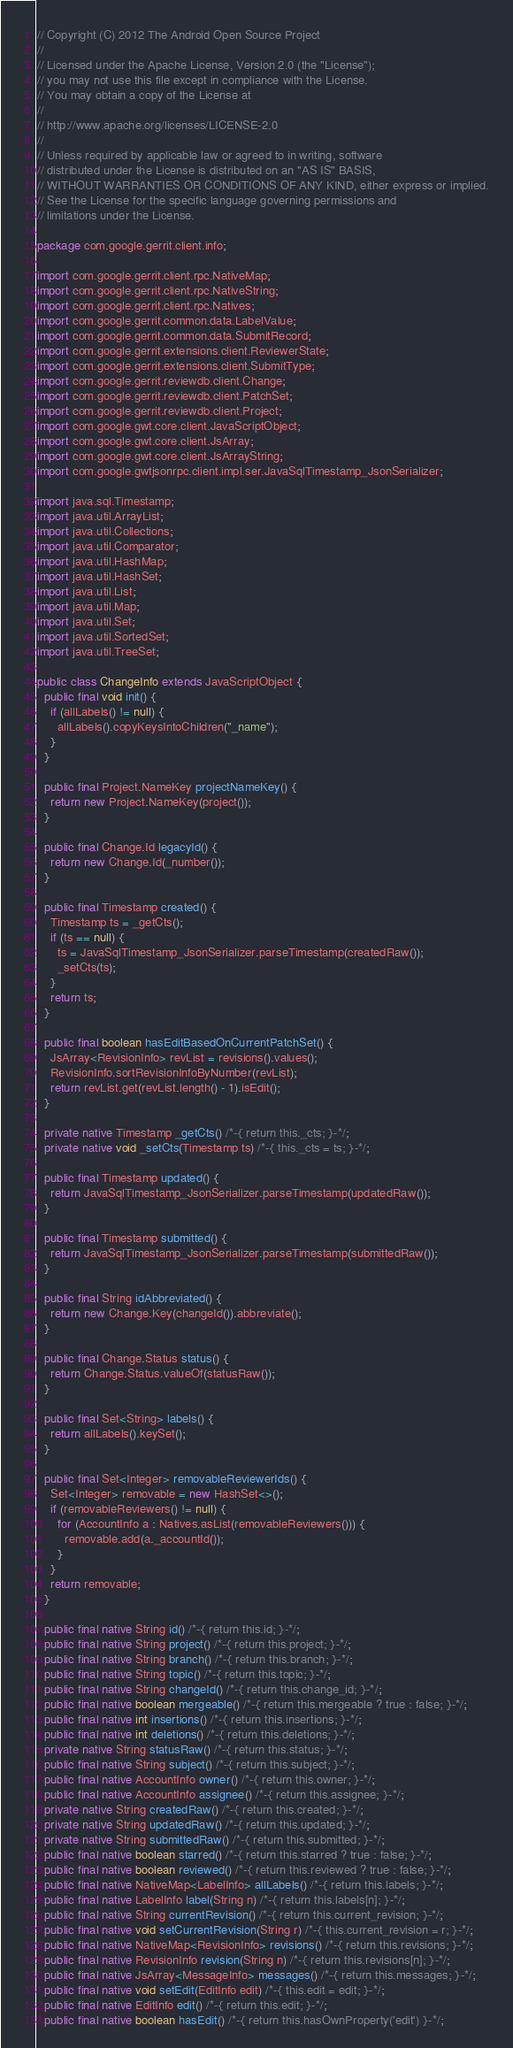<code> <loc_0><loc_0><loc_500><loc_500><_Java_>// Copyright (C) 2012 The Android Open Source Project
//
// Licensed under the Apache License, Version 2.0 (the "License");
// you may not use this file except in compliance with the License.
// You may obtain a copy of the License at
//
// http://www.apache.org/licenses/LICENSE-2.0
//
// Unless required by applicable law or agreed to in writing, software
// distributed under the License is distributed on an "AS IS" BASIS,
// WITHOUT WARRANTIES OR CONDITIONS OF ANY KIND, either express or implied.
// See the License for the specific language governing permissions and
// limitations under the License.

package com.google.gerrit.client.info;

import com.google.gerrit.client.rpc.NativeMap;
import com.google.gerrit.client.rpc.NativeString;
import com.google.gerrit.client.rpc.Natives;
import com.google.gerrit.common.data.LabelValue;
import com.google.gerrit.common.data.SubmitRecord;
import com.google.gerrit.extensions.client.ReviewerState;
import com.google.gerrit.extensions.client.SubmitType;
import com.google.gerrit.reviewdb.client.Change;
import com.google.gerrit.reviewdb.client.PatchSet;
import com.google.gerrit.reviewdb.client.Project;
import com.google.gwt.core.client.JavaScriptObject;
import com.google.gwt.core.client.JsArray;
import com.google.gwt.core.client.JsArrayString;
import com.google.gwtjsonrpc.client.impl.ser.JavaSqlTimestamp_JsonSerializer;

import java.sql.Timestamp;
import java.util.ArrayList;
import java.util.Collections;
import java.util.Comparator;
import java.util.HashMap;
import java.util.HashSet;
import java.util.List;
import java.util.Map;
import java.util.Set;
import java.util.SortedSet;
import java.util.TreeSet;

public class ChangeInfo extends JavaScriptObject {
  public final void init() {
    if (allLabels() != null) {
      allLabels().copyKeysIntoChildren("_name");
    }
  }

  public final Project.NameKey projectNameKey() {
    return new Project.NameKey(project());
  }

  public final Change.Id legacyId() {
    return new Change.Id(_number());
  }

  public final Timestamp created() {
    Timestamp ts = _getCts();
    if (ts == null) {
      ts = JavaSqlTimestamp_JsonSerializer.parseTimestamp(createdRaw());
      _setCts(ts);
    }
    return ts;
  }

  public final boolean hasEditBasedOnCurrentPatchSet() {
    JsArray<RevisionInfo> revList = revisions().values();
    RevisionInfo.sortRevisionInfoByNumber(revList);
    return revList.get(revList.length() - 1).isEdit();
  }

  private native Timestamp _getCts() /*-{ return this._cts; }-*/;
  private native void _setCts(Timestamp ts) /*-{ this._cts = ts; }-*/;

  public final Timestamp updated() {
    return JavaSqlTimestamp_JsonSerializer.parseTimestamp(updatedRaw());
  }

  public final Timestamp submitted() {
    return JavaSqlTimestamp_JsonSerializer.parseTimestamp(submittedRaw());
  }

  public final String idAbbreviated() {
    return new Change.Key(changeId()).abbreviate();
  }

  public final Change.Status status() {
    return Change.Status.valueOf(statusRaw());
  }

  public final Set<String> labels() {
    return allLabels().keySet();
  }

  public final Set<Integer> removableReviewerIds() {
    Set<Integer> removable = new HashSet<>();
    if (removableReviewers() != null) {
      for (AccountInfo a : Natives.asList(removableReviewers())) {
        removable.add(a._accountId());
      }
    }
    return removable;
  }

  public final native String id() /*-{ return this.id; }-*/;
  public final native String project() /*-{ return this.project; }-*/;
  public final native String branch() /*-{ return this.branch; }-*/;
  public final native String topic() /*-{ return this.topic; }-*/;
  public final native String changeId() /*-{ return this.change_id; }-*/;
  public final native boolean mergeable() /*-{ return this.mergeable ? true : false; }-*/;
  public final native int insertions() /*-{ return this.insertions; }-*/;
  public final native int deletions() /*-{ return this.deletions; }-*/;
  private native String statusRaw() /*-{ return this.status; }-*/;
  public final native String subject() /*-{ return this.subject; }-*/;
  public final native AccountInfo owner() /*-{ return this.owner; }-*/;
  public final native AccountInfo assignee() /*-{ return this.assignee; }-*/;
  private native String createdRaw() /*-{ return this.created; }-*/;
  private native String updatedRaw() /*-{ return this.updated; }-*/;
  private native String submittedRaw() /*-{ return this.submitted; }-*/;
  public final native boolean starred() /*-{ return this.starred ? true : false; }-*/;
  public final native boolean reviewed() /*-{ return this.reviewed ? true : false; }-*/;
  public final native NativeMap<LabelInfo> allLabels() /*-{ return this.labels; }-*/;
  public final native LabelInfo label(String n) /*-{ return this.labels[n]; }-*/;
  public final native String currentRevision() /*-{ return this.current_revision; }-*/;
  public final native void setCurrentRevision(String r) /*-{ this.current_revision = r; }-*/;
  public final native NativeMap<RevisionInfo> revisions() /*-{ return this.revisions; }-*/;
  public final native RevisionInfo revision(String n) /*-{ return this.revisions[n]; }-*/;
  public final native JsArray<MessageInfo> messages() /*-{ return this.messages; }-*/;
  public final native void setEdit(EditInfo edit) /*-{ this.edit = edit; }-*/;
  public final native EditInfo edit() /*-{ return this.edit; }-*/;
  public final native boolean hasEdit() /*-{ return this.hasOwnProperty('edit') }-*/;</code> 